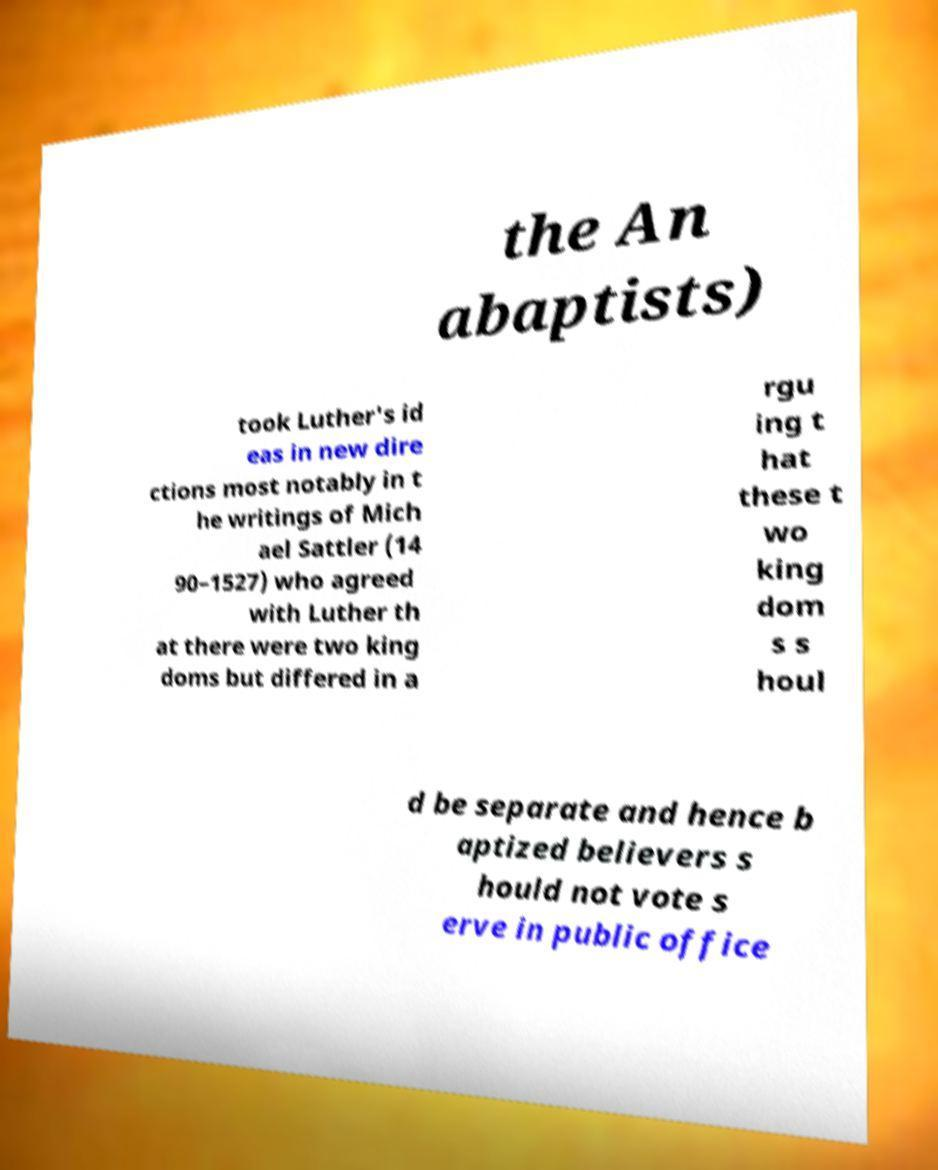Can you read and provide the text displayed in the image?This photo seems to have some interesting text. Can you extract and type it out for me? the An abaptists) took Luther's id eas in new dire ctions most notably in t he writings of Mich ael Sattler (14 90–1527) who agreed with Luther th at there were two king doms but differed in a rgu ing t hat these t wo king dom s s houl d be separate and hence b aptized believers s hould not vote s erve in public office 